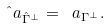<formula> <loc_0><loc_0><loc_500><loc_500>\hat { \ } a _ { \hat { \Gamma } ^ { \perp } } = \ a _ { \Gamma ^ { \perp } } .</formula> 